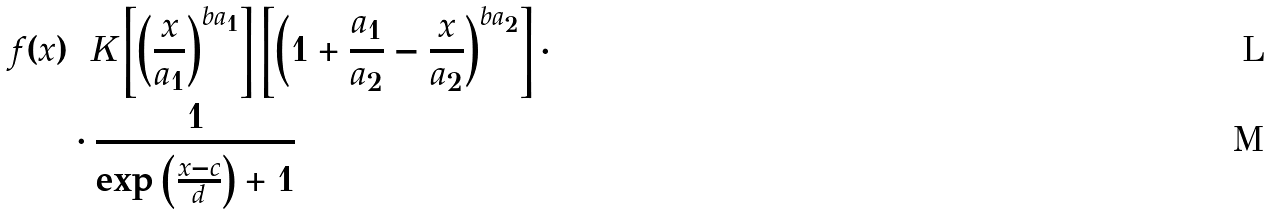Convert formula to latex. <formula><loc_0><loc_0><loc_500><loc_500>f ( x ) & = K \left [ \left ( \frac { x } { a _ { 1 } } \right ) ^ { b a _ { 1 } } \right ] \left [ \left ( 1 + \frac { a _ { 1 } } { a _ { 2 } } - \frac { x } { a _ { 2 } } \right ) ^ { b a _ { 2 } } \right ] \cdot \\ & \cdot \frac { 1 } { \exp \left ( \frac { x - c } { d } \right ) + 1 }</formula> 